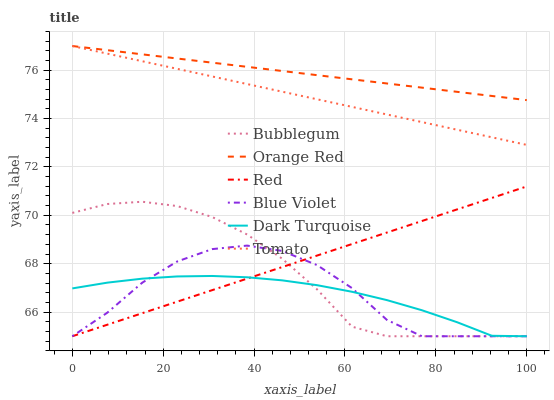Does Dark Turquoise have the minimum area under the curve?
Answer yes or no. Yes. Does Orange Red have the maximum area under the curve?
Answer yes or no. Yes. Does Bubblegum have the minimum area under the curve?
Answer yes or no. No. Does Bubblegum have the maximum area under the curve?
Answer yes or no. No. Is Red the smoothest?
Answer yes or no. Yes. Is Blue Violet the roughest?
Answer yes or no. Yes. Is Dark Turquoise the smoothest?
Answer yes or no. No. Is Dark Turquoise the roughest?
Answer yes or no. No. Does Dark Turquoise have the lowest value?
Answer yes or no. Yes. Does Orange Red have the lowest value?
Answer yes or no. No. Does Orange Red have the highest value?
Answer yes or no. Yes. Does Bubblegum have the highest value?
Answer yes or no. No. Is Bubblegum less than Orange Red?
Answer yes or no. Yes. Is Tomato greater than Blue Violet?
Answer yes or no. Yes. Does Orange Red intersect Tomato?
Answer yes or no. Yes. Is Orange Red less than Tomato?
Answer yes or no. No. Is Orange Red greater than Tomato?
Answer yes or no. No. Does Bubblegum intersect Orange Red?
Answer yes or no. No. 